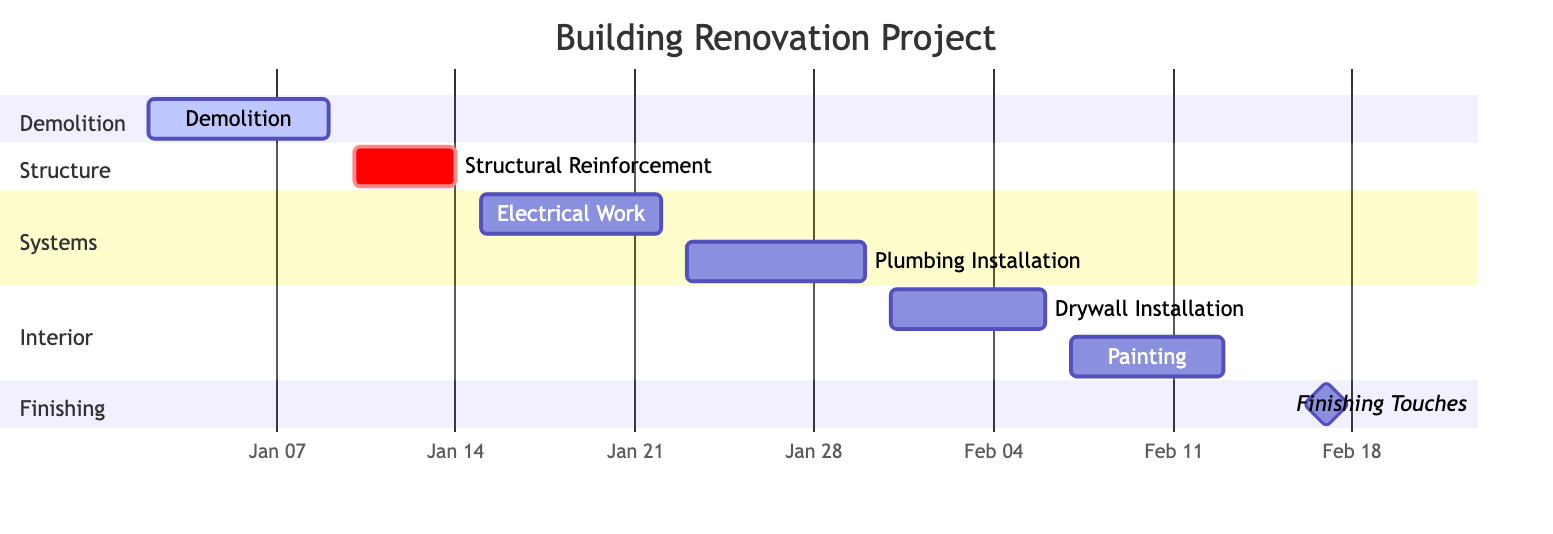What is the duration of the Demolition task? The Demolition task is listed with a duration of 7 days in the provided data.
Answer: 7 days What is the end date of the Plumbing Installation task? The Plumbing Installation task ends on January 30, 2024, as detailed in the data.
Answer: 2024-01-30 How many total tasks are outlined in the diagram? By counting all the tasks listed in the data (Demolition, Structural Reinforcement, Electrical Work, Plumbing Installation, Drywall Installation, Painting, Finishing Touches), there are 7 tasks in total.
Answer: 7 Which task starts immediately after Structural Reinforcement? The task that starts immediately after Structural Reinforcement is Electrical Work, which begins on January 15, 2024.
Answer: Electrical Work Which task has the shortest duration? Among the tasks listed, Structural Reinforcement has the shortest duration of 4 days.
Answer: 4 days When does the Finishing Touches task start? The Finishing Touches task starts on February 14, 2024, as indicated in the project schedule data.
Answer: 2024-02-14 What is the last task in the schedule? The last task in the schedule is Finishing Touches, which is scheduled to be completed on February 20, 2024.
Answer: Finishing Touches How many days are there between the end of Electrical Work and the start of Plumbing Installation? There are two days between the end of Electrical Work (January 22, 2024) and the start of Plumbing Installation (January 23, 2024).
Answer: 1 day Which section includes the task for Painting? The task for Painting is included in the Interior section of the Gantt Chart.
Answer: Interior 